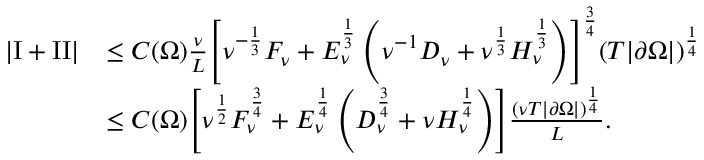Convert formula to latex. <formula><loc_0><loc_0><loc_500><loc_500>\begin{array} { r l } { \left | \mathrm I + I I \right | } & { \leq C ( \Omega ) \frac { \nu } { L } \left [ \nu ^ { - \frac { 1 } { 3 } } F _ { \nu } + E _ { \nu } ^ { \frac { 1 } { 3 } } \left ( \nu ^ { - 1 } D _ { \nu } + \nu ^ { \frac { 1 } { 3 } } H _ { \nu } ^ { \frac { 1 } { 3 } } \right ) \right ] ^ { \frac { 3 } { 4 } } ( T | \partial \Omega | ) ^ { \frac { 1 } { 4 } } } \\ & { \leq { C ( \Omega ) } \left [ \nu ^ { \frac { 1 } { 2 } } F _ { \nu } ^ { \frac { 3 } { 4 } } + E _ { \nu } ^ { \frac { 1 } { 4 } } \left ( D _ { \nu } ^ { \frac { 3 } { 4 } } + \nu H _ { \nu } ^ { \frac { 1 } { 4 } } \right ) \right ] \frac { ( \nu T | \partial \Omega | ) ^ { \frac { 1 } { 4 } } } L . } \end{array}</formula> 